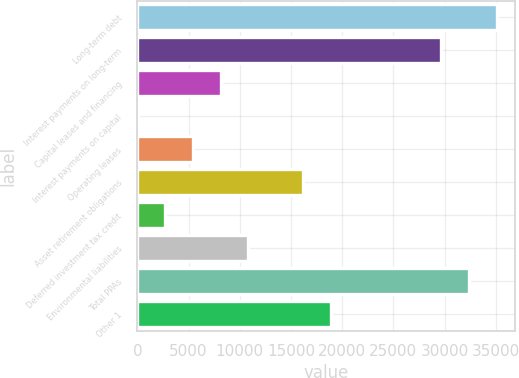<chart> <loc_0><loc_0><loc_500><loc_500><bar_chart><fcel>Long-term debt<fcel>Interest payments on long-term<fcel>Capital leases and financing<fcel>Interest payments on capital<fcel>Operating leases<fcel>Asset retirement obligations<fcel>Deferred investment tax credit<fcel>Environmental liabilities<fcel>Total PPAs<fcel>Other 1<nl><fcel>35075.6<fcel>29685.2<fcel>8123.6<fcel>38<fcel>5428.4<fcel>16209.2<fcel>2733.2<fcel>10818.8<fcel>32380.4<fcel>18904.4<nl></chart> 